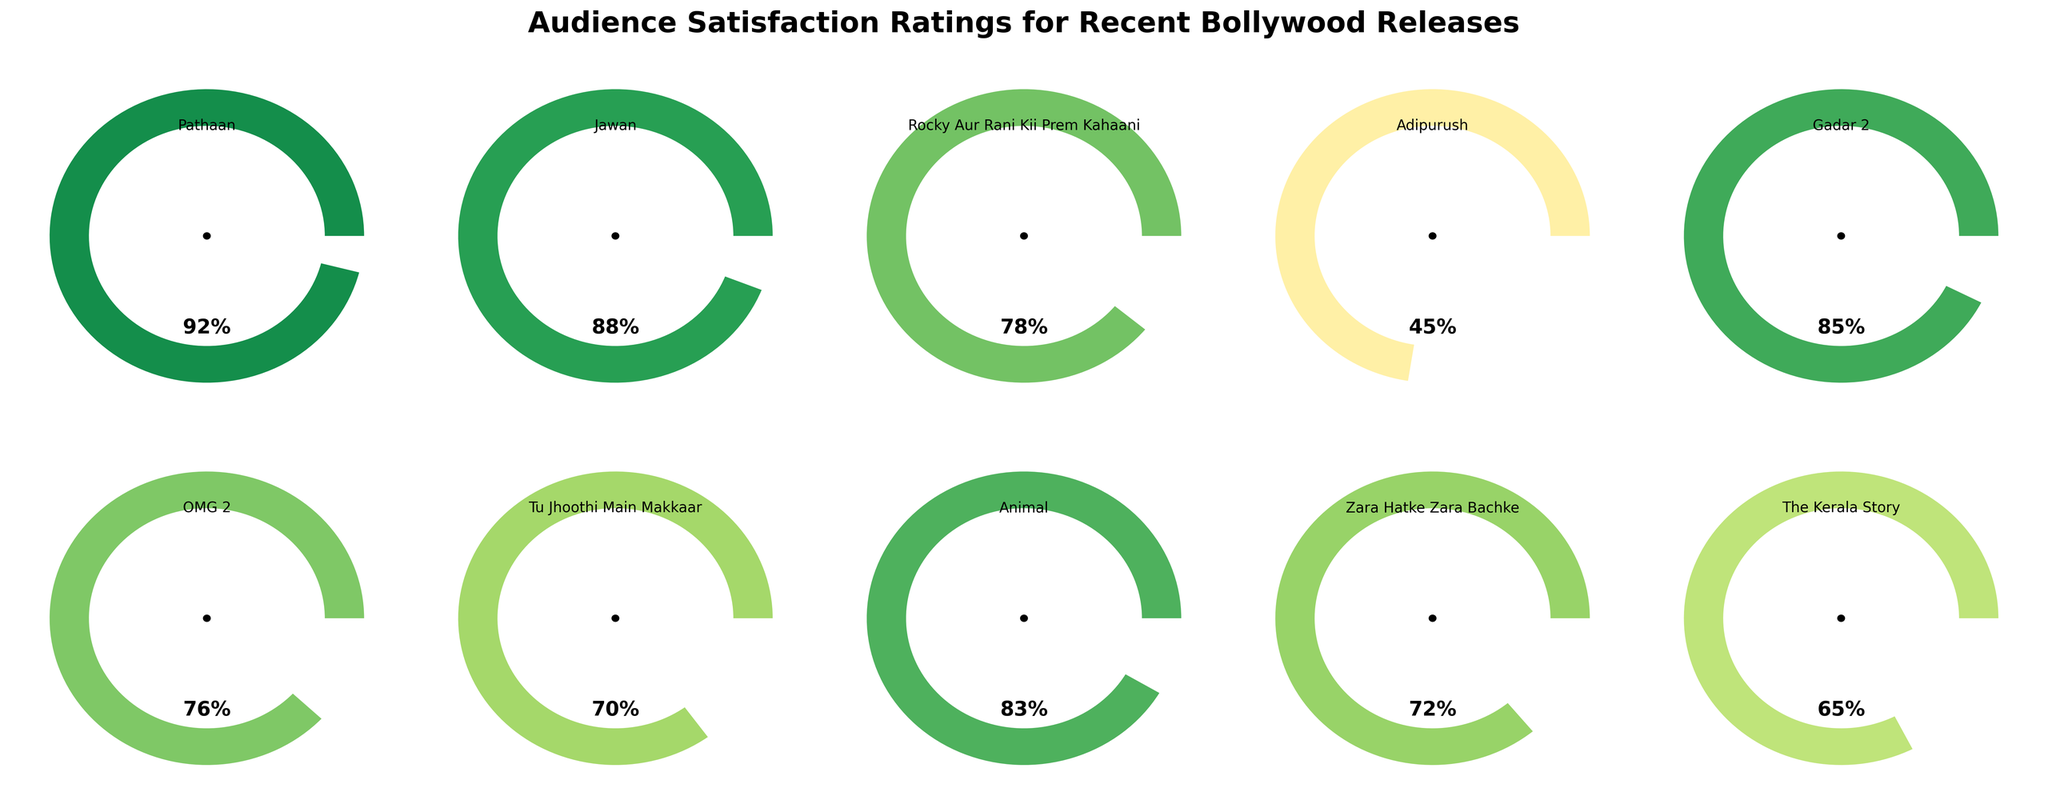What's the highest audience satisfaction rating among the recent Bollywood releases? Look at the gauge charts; the one with the highest percentage value represents the highest audience satisfaction rating. Pathaan shows 92%, which is the highest rating.
Answer: Pathaan with 92% What's the lowest audience satisfaction rating among the recent Bollywood releases? Look at the gauge charts for the movie with the lowest percentage value. Adipurush shows a 45% satisfaction rating, which is the lowest.
Answer: Adipurush with 45% What is the average audience satisfaction rating of all the listed movies? To find the average, add all the satisfaction ratings and divide by the number of movies. The ratings are: 92, 88, 78, 45, 85, 76, 70, 83, 72, 65. Sum = 754, number of movies = 10, average = 754/10.
Answer: 75.4 How many movies have a satisfaction rating of above 80? Identify the movies with satisfaction ratings above 80: Pathaan (92), Jawan (88), Gadar 2 (85), and Animal (83). There are 4 such movies.
Answer: 4 Which movies have ratings between 70 and 85 (inclusive)? Check the ratings and identify movies within this range: Rocky Aur Rani Kii Prem Kahaani (78), OMG 2 (76), Tu Jhoothi Main Makkaar (70), Animal (83), Zara Hatke Zara Bachke (72), and The Kerala Story (65 is excluded as it's below 70).
Answer: 5 movies: Rocky Aur Rani Kii Prem Kahaani, OMG 2, Tu Jhoothi Main Makkaar, Animal, Zara Hatke Zara Bachke How much higher is Pathaan’s satisfaction rating compared to Adipurush? Subtract Adipurush's rating from Pathaan's rating: 92 (Pathaan) - 45 (Adipurush). The difference is 47.
Answer: 47 Which movie has a satisfaction rating closest to 70? Compare the ratings to 70, identifying the closest: Tu Jhoothi Main Makkaar (70) is exactly 70. Zara Hatke Zara Bachke (72) is closest if no exact answer allowed.
Answer: Tu Jhoothi Main Makkaar Arrange the top 3 movies in descending order of satisfaction rating. Look at the gauge charts and select the top 3 ratings: Pathaan (92), Jawan (88), Gadar 2 (85). The order from highest to lowest: Pathaan, Jawan, Gadar 2.
Answer: Pathaan, Jawan, Gadar 2 What percentage of movies have a satisfaction rating of 80 or higher? Count movies with a rating 80 or higher (Pathaan, Jawan, Gadar 2, Animal; 4 movies). The total number of movies is 10. Percentage = (4/10) * 100.
Answer: 40% Which movie has a slightly lower satisfaction rating than Gadar 2? Identify the movie just below Gadar 2's 85% rating: Animal has an 83% rating, which is slightly lower.
Answer: Animal with 83% 